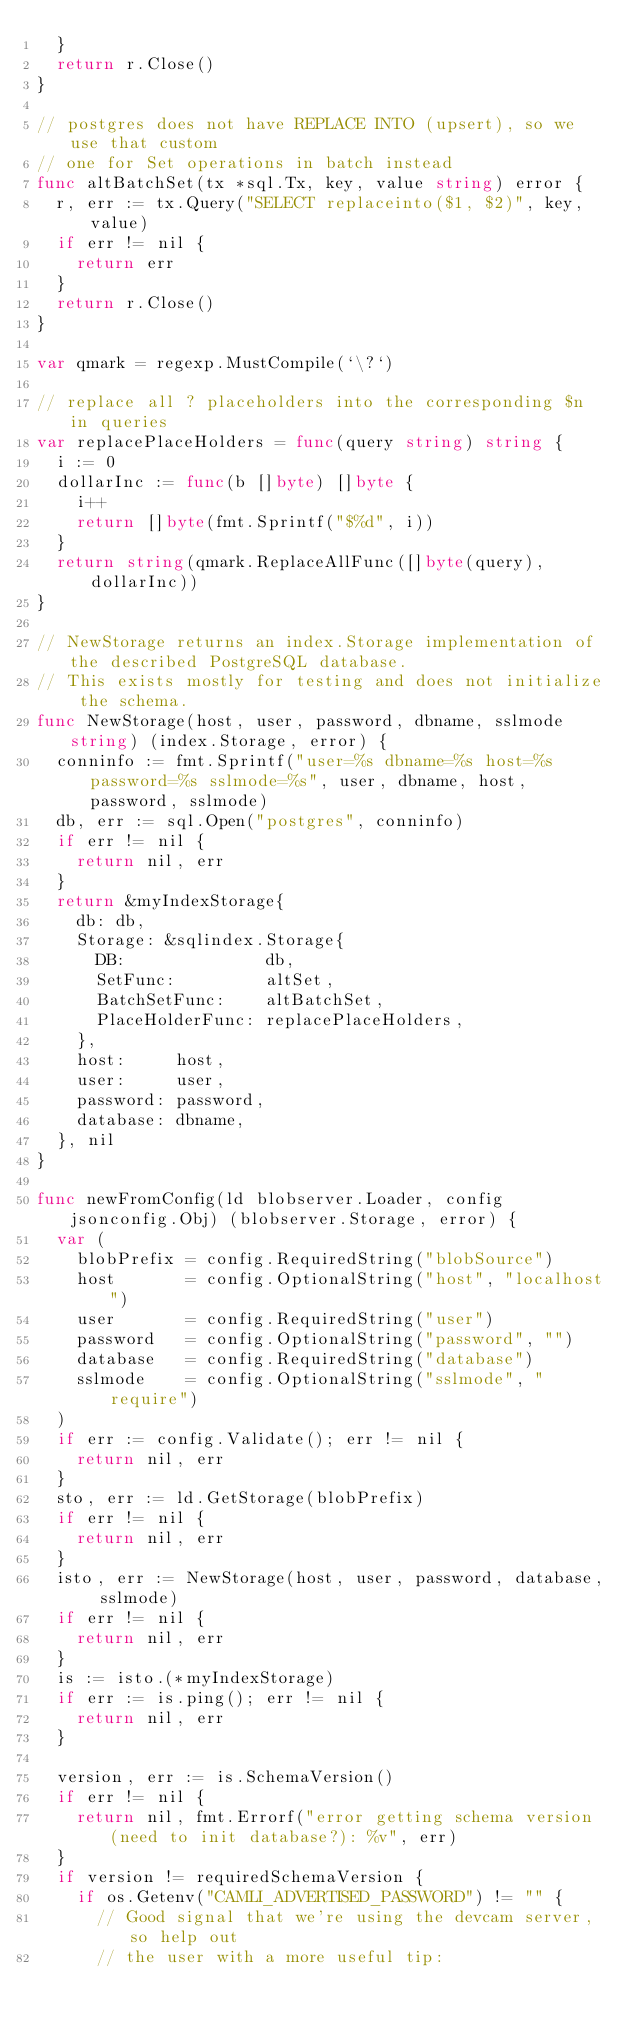Convert code to text. <code><loc_0><loc_0><loc_500><loc_500><_Go_>	}
	return r.Close()
}

// postgres does not have REPLACE INTO (upsert), so we use that custom
// one for Set operations in batch instead
func altBatchSet(tx *sql.Tx, key, value string) error {
	r, err := tx.Query("SELECT replaceinto($1, $2)", key, value)
	if err != nil {
		return err
	}
	return r.Close()
}

var qmark = regexp.MustCompile(`\?`)

// replace all ? placeholders into the corresponding $n in queries
var replacePlaceHolders = func(query string) string {
	i := 0
	dollarInc := func(b []byte) []byte {
		i++
		return []byte(fmt.Sprintf("$%d", i))
	}
	return string(qmark.ReplaceAllFunc([]byte(query), dollarInc))
}

// NewStorage returns an index.Storage implementation of the described PostgreSQL database.
// This exists mostly for testing and does not initialize the schema.
func NewStorage(host, user, password, dbname, sslmode string) (index.Storage, error) {
	conninfo := fmt.Sprintf("user=%s dbname=%s host=%s password=%s sslmode=%s", user, dbname, host, password, sslmode)
	db, err := sql.Open("postgres", conninfo)
	if err != nil {
		return nil, err
	}
	return &myIndexStorage{
		db: db,
		Storage: &sqlindex.Storage{
			DB:              db,
			SetFunc:         altSet,
			BatchSetFunc:    altBatchSet,
			PlaceHolderFunc: replacePlaceHolders,
		},
		host:     host,
		user:     user,
		password: password,
		database: dbname,
	}, nil
}

func newFromConfig(ld blobserver.Loader, config jsonconfig.Obj) (blobserver.Storage, error) {
	var (
		blobPrefix = config.RequiredString("blobSource")
		host       = config.OptionalString("host", "localhost")
		user       = config.RequiredString("user")
		password   = config.OptionalString("password", "")
		database   = config.RequiredString("database")
		sslmode    = config.OptionalString("sslmode", "require")
	)
	if err := config.Validate(); err != nil {
		return nil, err
	}
	sto, err := ld.GetStorage(blobPrefix)
	if err != nil {
		return nil, err
	}
	isto, err := NewStorage(host, user, password, database, sslmode)
	if err != nil {
		return nil, err
	}
	is := isto.(*myIndexStorage)
	if err := is.ping(); err != nil {
		return nil, err
	}

	version, err := is.SchemaVersion()
	if err != nil {
		return nil, fmt.Errorf("error getting schema version (need to init database?): %v", err)
	}
	if version != requiredSchemaVersion {
		if os.Getenv("CAMLI_ADVERTISED_PASSWORD") != "" {
			// Good signal that we're using the devcam server, so help out
			// the user with a more useful tip:</code> 